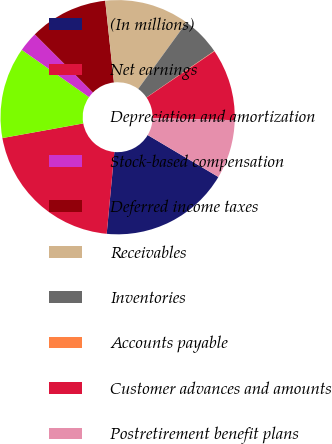Convert chart to OTSL. <chart><loc_0><loc_0><loc_500><loc_500><pie_chart><fcel>(In millions)<fcel>Net earnings<fcel>Depreciation and amortization<fcel>Stock-based compensation<fcel>Deferred income taxes<fcel>Receivables<fcel>Inventories<fcel>Accounts payable<fcel>Customer advances and amounts<fcel>Postretirement benefit plans<nl><fcel>17.97%<fcel>20.66%<fcel>12.6%<fcel>2.75%<fcel>10.81%<fcel>11.7%<fcel>5.43%<fcel>0.06%<fcel>9.91%<fcel>8.12%<nl></chart> 